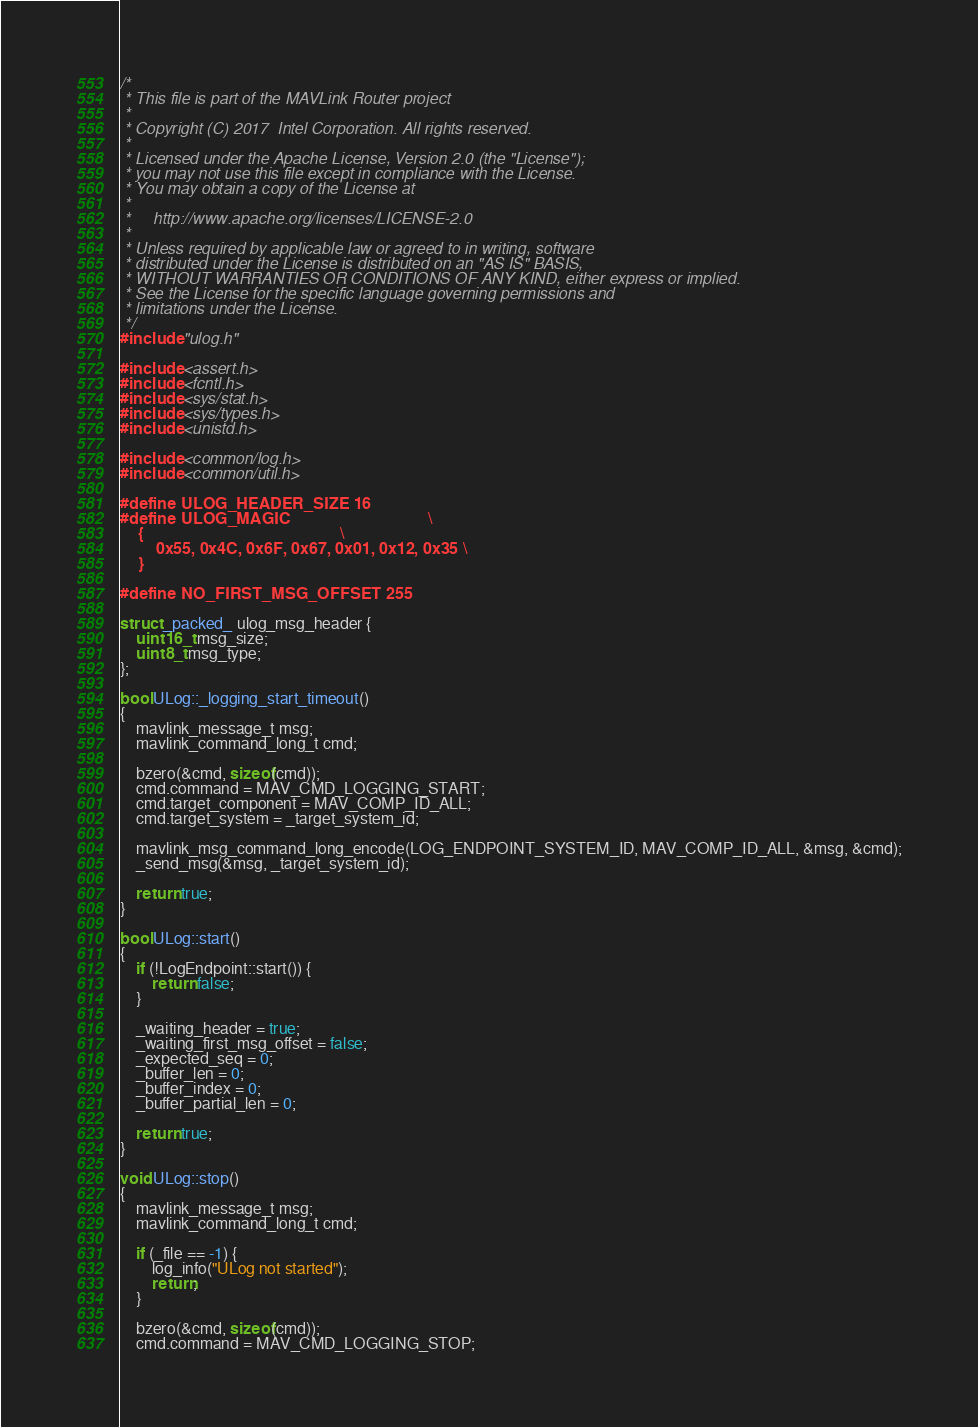Convert code to text. <code><loc_0><loc_0><loc_500><loc_500><_C++_>/*
 * This file is part of the MAVLink Router project
 *
 * Copyright (C) 2017  Intel Corporation. All rights reserved.
 *
 * Licensed under the Apache License, Version 2.0 (the "License");
 * you may not use this file except in compliance with the License.
 * You may obtain a copy of the License at
 *
 *     http://www.apache.org/licenses/LICENSE-2.0
 *
 * Unless required by applicable law or agreed to in writing, software
 * distributed under the License is distributed on an "AS IS" BASIS,
 * WITHOUT WARRANTIES OR CONDITIONS OF ANY KIND, either express or implied.
 * See the License for the specific language governing permissions and
 * limitations under the License.
 */
#include "ulog.h"

#include <assert.h>
#include <fcntl.h>
#include <sys/stat.h>
#include <sys/types.h>
#include <unistd.h>

#include <common/log.h>
#include <common/util.h>

#define ULOG_HEADER_SIZE 16
#define ULOG_MAGIC                               \
    {                                            \
        0x55, 0x4C, 0x6F, 0x67, 0x01, 0x12, 0x35 \
    }

#define NO_FIRST_MSG_OFFSET 255

struct _packed_ ulog_msg_header {
    uint16_t msg_size;
    uint8_t msg_type;
};

bool ULog::_logging_start_timeout()
{
    mavlink_message_t msg;
    mavlink_command_long_t cmd;

    bzero(&cmd, sizeof(cmd));
    cmd.command = MAV_CMD_LOGGING_START;
    cmd.target_component = MAV_COMP_ID_ALL;
    cmd.target_system = _target_system_id;

    mavlink_msg_command_long_encode(LOG_ENDPOINT_SYSTEM_ID, MAV_COMP_ID_ALL, &msg, &cmd);
    _send_msg(&msg, _target_system_id);

    return true;
}

bool ULog::start()
{
    if (!LogEndpoint::start()) {
        return false;
    }

    _waiting_header = true;
    _waiting_first_msg_offset = false;
    _expected_seq = 0;
    _buffer_len = 0;
    _buffer_index = 0;
    _buffer_partial_len = 0;

    return true;
}

void ULog::stop()
{
    mavlink_message_t msg;
    mavlink_command_long_t cmd;

    if (_file == -1) {
        log_info("ULog not started");
        return;
    }

    bzero(&cmd, sizeof(cmd));
    cmd.command = MAV_CMD_LOGGING_STOP;</code> 